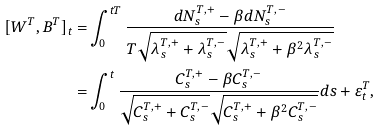<formula> <loc_0><loc_0><loc_500><loc_500>[ W ^ { T } , B ^ { T } ] _ { t } = & \int _ { 0 } ^ { t T } \frac { d N _ { s } ^ { T , + } - \beta d N _ { s } ^ { T , - } } { T \sqrt { \lambda _ { s } ^ { T , + } + \lambda _ { s } ^ { T , - } } \sqrt { \lambda _ { s } ^ { T , + } + \beta ^ { 2 } \lambda _ { s } ^ { T , - } } } \\ = & \int _ { 0 } ^ { t } \frac { C _ { s } ^ { T , + } - \beta C _ { s } ^ { T , - } } { \sqrt { C _ { s } ^ { T , + } + C _ { s } ^ { T , - } } \sqrt { C _ { s } ^ { T , + } + \beta ^ { 2 } C _ { s } ^ { T , - } } } d s + \varepsilon _ { t } ^ { T } ,</formula> 